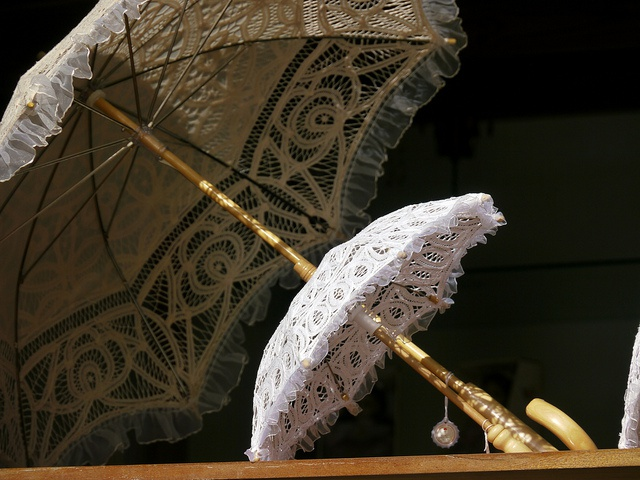Describe the objects in this image and their specific colors. I can see umbrella in black and gray tones and umbrella in black, lightgray, gray, and darkgray tones in this image. 